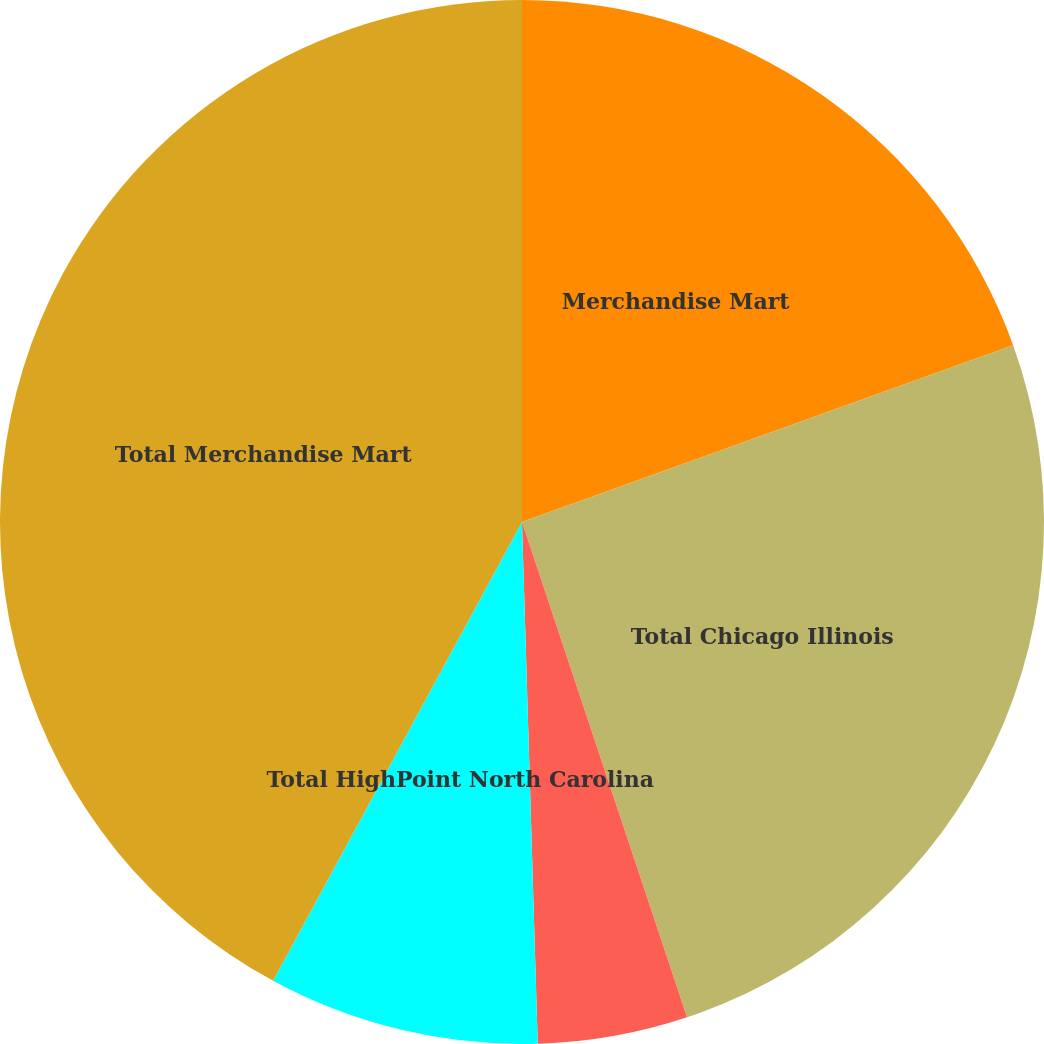Convert chart to OTSL. <chart><loc_0><loc_0><loc_500><loc_500><pie_chart><fcel>Merchandise Mart<fcel>Total Chicago Illinois<fcel>Market Square Complex<fcel>Total HighPoint North Carolina<fcel>Total Merchandise Mart<nl><fcel>19.5%<fcel>25.38%<fcel>4.64%<fcel>8.39%<fcel>42.09%<nl></chart> 